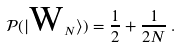Convert formula to latex. <formula><loc_0><loc_0><loc_500><loc_500>\mathcal { P } ( | \text {W} _ { N } \rangle ) = \frac { 1 } { 2 } + \frac { 1 } { 2 N } \, .</formula> 